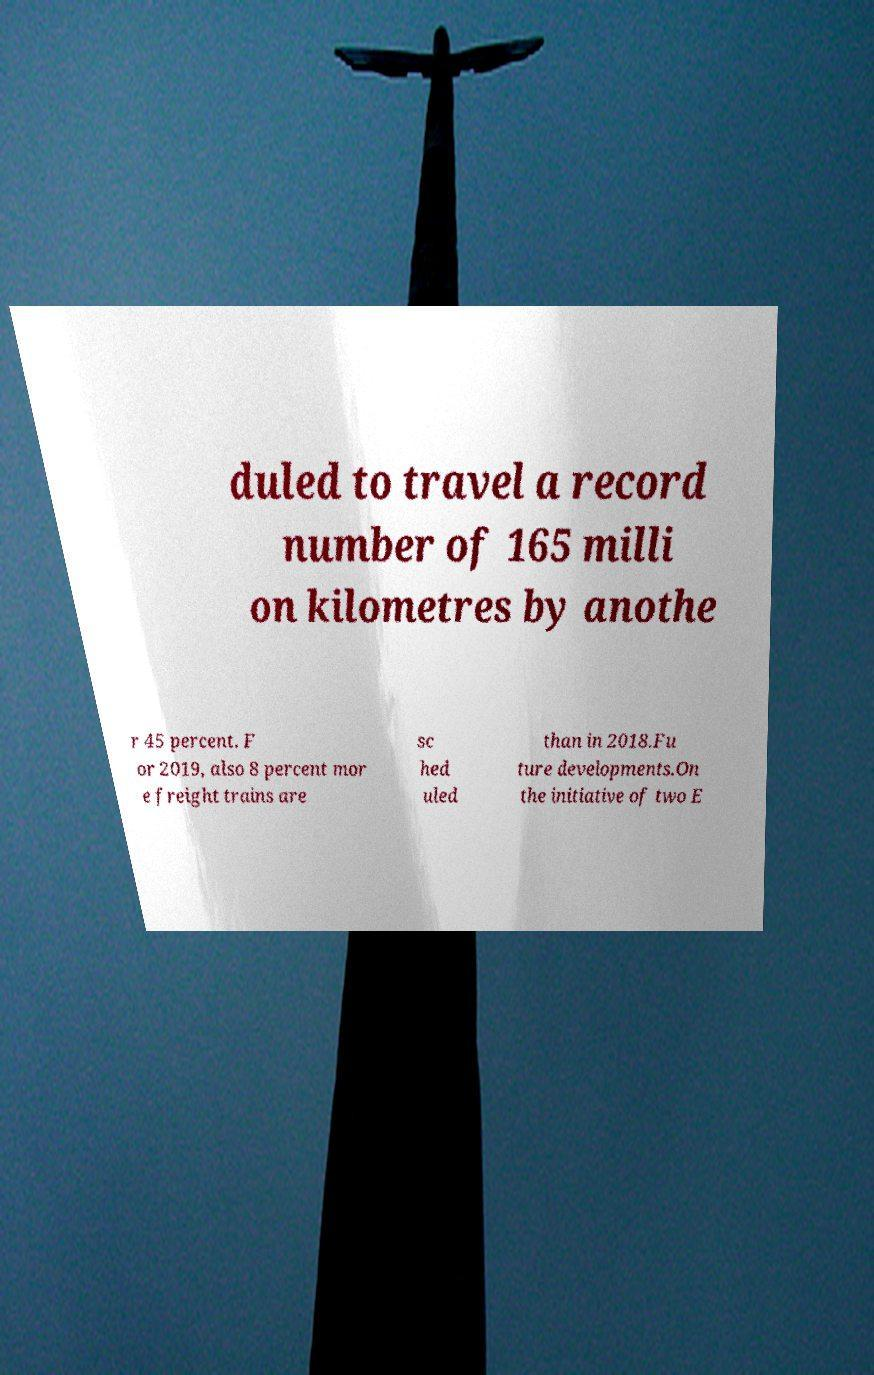Could you assist in decoding the text presented in this image and type it out clearly? duled to travel a record number of 165 milli on kilometres by anothe r 45 percent. F or 2019, also 8 percent mor e freight trains are sc hed uled than in 2018.Fu ture developments.On the initiative of two E 